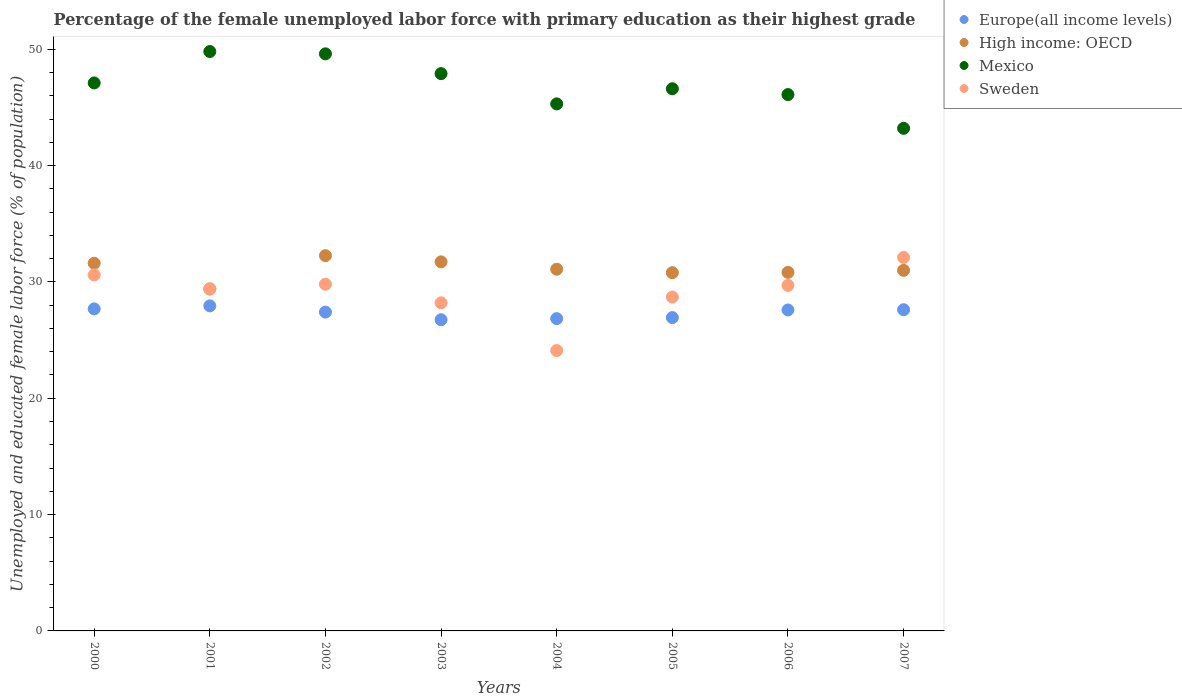How many different coloured dotlines are there?
Your answer should be compact. 4. Is the number of dotlines equal to the number of legend labels?
Ensure brevity in your answer.  Yes. What is the percentage of the unemployed female labor force with primary education in High income: OECD in 2000?
Offer a terse response. 31.6. Across all years, what is the maximum percentage of the unemployed female labor force with primary education in Europe(all income levels)?
Offer a terse response. 27.94. Across all years, what is the minimum percentage of the unemployed female labor force with primary education in Sweden?
Make the answer very short. 24.1. In which year was the percentage of the unemployed female labor force with primary education in Europe(all income levels) maximum?
Give a very brief answer. 2001. In which year was the percentage of the unemployed female labor force with primary education in Sweden minimum?
Give a very brief answer. 2004. What is the total percentage of the unemployed female labor force with primary education in Mexico in the graph?
Your response must be concise. 375.6. What is the difference between the percentage of the unemployed female labor force with primary education in Sweden in 2000 and that in 2006?
Offer a very short reply. 0.9. What is the difference between the percentage of the unemployed female labor force with primary education in Europe(all income levels) in 2004 and the percentage of the unemployed female labor force with primary education in Mexico in 2005?
Provide a short and direct response. -19.76. What is the average percentage of the unemployed female labor force with primary education in Europe(all income levels) per year?
Your response must be concise. 27.34. In the year 2006, what is the difference between the percentage of the unemployed female labor force with primary education in Mexico and percentage of the unemployed female labor force with primary education in Sweden?
Offer a terse response. 16.4. In how many years, is the percentage of the unemployed female labor force with primary education in Mexico greater than 8 %?
Ensure brevity in your answer.  8. What is the ratio of the percentage of the unemployed female labor force with primary education in High income: OECD in 2000 to that in 2007?
Offer a terse response. 1.02. Is the percentage of the unemployed female labor force with primary education in High income: OECD in 2001 less than that in 2005?
Make the answer very short. Yes. What is the difference between the highest and the second highest percentage of the unemployed female labor force with primary education in High income: OECD?
Your answer should be compact. 0.53. What is the difference between the highest and the lowest percentage of the unemployed female labor force with primary education in Mexico?
Make the answer very short. 6.6. Is it the case that in every year, the sum of the percentage of the unemployed female labor force with primary education in Mexico and percentage of the unemployed female labor force with primary education in Europe(all income levels)  is greater than the sum of percentage of the unemployed female labor force with primary education in High income: OECD and percentage of the unemployed female labor force with primary education in Sweden?
Your answer should be compact. Yes. Is it the case that in every year, the sum of the percentage of the unemployed female labor force with primary education in Europe(all income levels) and percentage of the unemployed female labor force with primary education in Mexico  is greater than the percentage of the unemployed female labor force with primary education in High income: OECD?
Keep it short and to the point. Yes. Does the percentage of the unemployed female labor force with primary education in High income: OECD monotonically increase over the years?
Your response must be concise. No. Is the percentage of the unemployed female labor force with primary education in Mexico strictly greater than the percentage of the unemployed female labor force with primary education in Sweden over the years?
Make the answer very short. Yes. Is the percentage of the unemployed female labor force with primary education in Europe(all income levels) strictly less than the percentage of the unemployed female labor force with primary education in High income: OECD over the years?
Your answer should be very brief. Yes. How many years are there in the graph?
Provide a succinct answer. 8. What is the difference between two consecutive major ticks on the Y-axis?
Your response must be concise. 10. Does the graph contain any zero values?
Give a very brief answer. No. Where does the legend appear in the graph?
Provide a short and direct response. Top right. How many legend labels are there?
Provide a succinct answer. 4. How are the legend labels stacked?
Give a very brief answer. Vertical. What is the title of the graph?
Offer a very short reply. Percentage of the female unemployed labor force with primary education as their highest grade. Does "Malta" appear as one of the legend labels in the graph?
Give a very brief answer. No. What is the label or title of the X-axis?
Your answer should be compact. Years. What is the label or title of the Y-axis?
Provide a succinct answer. Unemployed and educated female labor force (% of population). What is the Unemployed and educated female labor force (% of population) of Europe(all income levels) in 2000?
Provide a succinct answer. 27.68. What is the Unemployed and educated female labor force (% of population) of High income: OECD in 2000?
Make the answer very short. 31.6. What is the Unemployed and educated female labor force (% of population) in Mexico in 2000?
Offer a terse response. 47.1. What is the Unemployed and educated female labor force (% of population) of Sweden in 2000?
Make the answer very short. 30.6. What is the Unemployed and educated female labor force (% of population) in Europe(all income levels) in 2001?
Ensure brevity in your answer.  27.94. What is the Unemployed and educated female labor force (% of population) in High income: OECD in 2001?
Your answer should be very brief. 29.39. What is the Unemployed and educated female labor force (% of population) in Mexico in 2001?
Offer a terse response. 49.8. What is the Unemployed and educated female labor force (% of population) in Sweden in 2001?
Provide a short and direct response. 29.4. What is the Unemployed and educated female labor force (% of population) of Europe(all income levels) in 2002?
Offer a very short reply. 27.4. What is the Unemployed and educated female labor force (% of population) of High income: OECD in 2002?
Provide a short and direct response. 32.26. What is the Unemployed and educated female labor force (% of population) of Mexico in 2002?
Offer a terse response. 49.6. What is the Unemployed and educated female labor force (% of population) of Sweden in 2002?
Offer a very short reply. 29.8. What is the Unemployed and educated female labor force (% of population) of Europe(all income levels) in 2003?
Offer a terse response. 26.75. What is the Unemployed and educated female labor force (% of population) in High income: OECD in 2003?
Your answer should be very brief. 31.72. What is the Unemployed and educated female labor force (% of population) in Mexico in 2003?
Your answer should be very brief. 47.9. What is the Unemployed and educated female labor force (% of population) of Sweden in 2003?
Provide a short and direct response. 28.2. What is the Unemployed and educated female labor force (% of population) in Europe(all income levels) in 2004?
Offer a terse response. 26.84. What is the Unemployed and educated female labor force (% of population) of High income: OECD in 2004?
Your response must be concise. 31.09. What is the Unemployed and educated female labor force (% of population) in Mexico in 2004?
Offer a very short reply. 45.3. What is the Unemployed and educated female labor force (% of population) in Sweden in 2004?
Your answer should be compact. 24.1. What is the Unemployed and educated female labor force (% of population) in Europe(all income levels) in 2005?
Your answer should be compact. 26.93. What is the Unemployed and educated female labor force (% of population) in High income: OECD in 2005?
Your response must be concise. 30.79. What is the Unemployed and educated female labor force (% of population) in Mexico in 2005?
Make the answer very short. 46.6. What is the Unemployed and educated female labor force (% of population) in Sweden in 2005?
Make the answer very short. 28.7. What is the Unemployed and educated female labor force (% of population) of Europe(all income levels) in 2006?
Keep it short and to the point. 27.59. What is the Unemployed and educated female labor force (% of population) in High income: OECD in 2006?
Offer a terse response. 30.82. What is the Unemployed and educated female labor force (% of population) of Mexico in 2006?
Ensure brevity in your answer.  46.1. What is the Unemployed and educated female labor force (% of population) of Sweden in 2006?
Offer a very short reply. 29.7. What is the Unemployed and educated female labor force (% of population) in Europe(all income levels) in 2007?
Provide a short and direct response. 27.61. What is the Unemployed and educated female labor force (% of population) of High income: OECD in 2007?
Give a very brief answer. 30.99. What is the Unemployed and educated female labor force (% of population) in Mexico in 2007?
Provide a succinct answer. 43.2. What is the Unemployed and educated female labor force (% of population) of Sweden in 2007?
Your response must be concise. 32.1. Across all years, what is the maximum Unemployed and educated female labor force (% of population) in Europe(all income levels)?
Ensure brevity in your answer.  27.94. Across all years, what is the maximum Unemployed and educated female labor force (% of population) of High income: OECD?
Your answer should be very brief. 32.26. Across all years, what is the maximum Unemployed and educated female labor force (% of population) in Mexico?
Your answer should be very brief. 49.8. Across all years, what is the maximum Unemployed and educated female labor force (% of population) in Sweden?
Provide a succinct answer. 32.1. Across all years, what is the minimum Unemployed and educated female labor force (% of population) in Europe(all income levels)?
Keep it short and to the point. 26.75. Across all years, what is the minimum Unemployed and educated female labor force (% of population) of High income: OECD?
Provide a succinct answer. 29.39. Across all years, what is the minimum Unemployed and educated female labor force (% of population) of Mexico?
Provide a short and direct response. 43.2. Across all years, what is the minimum Unemployed and educated female labor force (% of population) in Sweden?
Provide a short and direct response. 24.1. What is the total Unemployed and educated female labor force (% of population) in Europe(all income levels) in the graph?
Offer a terse response. 218.74. What is the total Unemployed and educated female labor force (% of population) of High income: OECD in the graph?
Your answer should be very brief. 248.66. What is the total Unemployed and educated female labor force (% of population) in Mexico in the graph?
Offer a very short reply. 375.6. What is the total Unemployed and educated female labor force (% of population) of Sweden in the graph?
Provide a succinct answer. 232.6. What is the difference between the Unemployed and educated female labor force (% of population) in Europe(all income levels) in 2000 and that in 2001?
Give a very brief answer. -0.26. What is the difference between the Unemployed and educated female labor force (% of population) of High income: OECD in 2000 and that in 2001?
Make the answer very short. 2.21. What is the difference between the Unemployed and educated female labor force (% of population) in Mexico in 2000 and that in 2001?
Provide a short and direct response. -2.7. What is the difference between the Unemployed and educated female labor force (% of population) in Sweden in 2000 and that in 2001?
Make the answer very short. 1.2. What is the difference between the Unemployed and educated female labor force (% of population) in Europe(all income levels) in 2000 and that in 2002?
Give a very brief answer. 0.28. What is the difference between the Unemployed and educated female labor force (% of population) in High income: OECD in 2000 and that in 2002?
Your response must be concise. -0.65. What is the difference between the Unemployed and educated female labor force (% of population) in Mexico in 2000 and that in 2002?
Offer a terse response. -2.5. What is the difference between the Unemployed and educated female labor force (% of population) in Sweden in 2000 and that in 2002?
Provide a short and direct response. 0.8. What is the difference between the Unemployed and educated female labor force (% of population) in Europe(all income levels) in 2000 and that in 2003?
Provide a short and direct response. 0.93. What is the difference between the Unemployed and educated female labor force (% of population) of High income: OECD in 2000 and that in 2003?
Provide a succinct answer. -0.12. What is the difference between the Unemployed and educated female labor force (% of population) of Mexico in 2000 and that in 2003?
Ensure brevity in your answer.  -0.8. What is the difference between the Unemployed and educated female labor force (% of population) of Sweden in 2000 and that in 2003?
Ensure brevity in your answer.  2.4. What is the difference between the Unemployed and educated female labor force (% of population) of Europe(all income levels) in 2000 and that in 2004?
Provide a succinct answer. 0.84. What is the difference between the Unemployed and educated female labor force (% of population) in High income: OECD in 2000 and that in 2004?
Provide a succinct answer. 0.51. What is the difference between the Unemployed and educated female labor force (% of population) in Sweden in 2000 and that in 2004?
Make the answer very short. 6.5. What is the difference between the Unemployed and educated female labor force (% of population) of Europe(all income levels) in 2000 and that in 2005?
Your response must be concise. 0.75. What is the difference between the Unemployed and educated female labor force (% of population) in High income: OECD in 2000 and that in 2005?
Keep it short and to the point. 0.81. What is the difference between the Unemployed and educated female labor force (% of population) of Mexico in 2000 and that in 2005?
Your response must be concise. 0.5. What is the difference between the Unemployed and educated female labor force (% of population) of Europe(all income levels) in 2000 and that in 2006?
Give a very brief answer. 0.09. What is the difference between the Unemployed and educated female labor force (% of population) of High income: OECD in 2000 and that in 2006?
Ensure brevity in your answer.  0.79. What is the difference between the Unemployed and educated female labor force (% of population) of Sweden in 2000 and that in 2006?
Make the answer very short. 0.9. What is the difference between the Unemployed and educated female labor force (% of population) in Europe(all income levels) in 2000 and that in 2007?
Your response must be concise. 0.07. What is the difference between the Unemployed and educated female labor force (% of population) of High income: OECD in 2000 and that in 2007?
Make the answer very short. 0.61. What is the difference between the Unemployed and educated female labor force (% of population) in Europe(all income levels) in 2001 and that in 2002?
Provide a short and direct response. 0.53. What is the difference between the Unemployed and educated female labor force (% of population) in High income: OECD in 2001 and that in 2002?
Offer a very short reply. -2.86. What is the difference between the Unemployed and educated female labor force (% of population) in Mexico in 2001 and that in 2002?
Keep it short and to the point. 0.2. What is the difference between the Unemployed and educated female labor force (% of population) in Sweden in 2001 and that in 2002?
Your answer should be compact. -0.4. What is the difference between the Unemployed and educated female labor force (% of population) in Europe(all income levels) in 2001 and that in 2003?
Your response must be concise. 1.19. What is the difference between the Unemployed and educated female labor force (% of population) in High income: OECD in 2001 and that in 2003?
Make the answer very short. -2.33. What is the difference between the Unemployed and educated female labor force (% of population) of Mexico in 2001 and that in 2003?
Offer a very short reply. 1.9. What is the difference between the Unemployed and educated female labor force (% of population) in Europe(all income levels) in 2001 and that in 2004?
Provide a succinct answer. 1.1. What is the difference between the Unemployed and educated female labor force (% of population) of High income: OECD in 2001 and that in 2004?
Make the answer very short. -1.7. What is the difference between the Unemployed and educated female labor force (% of population) in Sweden in 2001 and that in 2004?
Your answer should be very brief. 5.3. What is the difference between the Unemployed and educated female labor force (% of population) of Europe(all income levels) in 2001 and that in 2005?
Your answer should be compact. 1.01. What is the difference between the Unemployed and educated female labor force (% of population) of High income: OECD in 2001 and that in 2005?
Offer a terse response. -1.4. What is the difference between the Unemployed and educated female labor force (% of population) of Mexico in 2001 and that in 2005?
Offer a terse response. 3.2. What is the difference between the Unemployed and educated female labor force (% of population) in Europe(all income levels) in 2001 and that in 2006?
Provide a succinct answer. 0.35. What is the difference between the Unemployed and educated female labor force (% of population) of High income: OECD in 2001 and that in 2006?
Offer a terse response. -1.42. What is the difference between the Unemployed and educated female labor force (% of population) of Mexico in 2001 and that in 2006?
Your answer should be compact. 3.7. What is the difference between the Unemployed and educated female labor force (% of population) in Europe(all income levels) in 2001 and that in 2007?
Make the answer very short. 0.33. What is the difference between the Unemployed and educated female labor force (% of population) in High income: OECD in 2001 and that in 2007?
Provide a short and direct response. -1.6. What is the difference between the Unemployed and educated female labor force (% of population) of Mexico in 2001 and that in 2007?
Provide a succinct answer. 6.6. What is the difference between the Unemployed and educated female labor force (% of population) in Sweden in 2001 and that in 2007?
Keep it short and to the point. -2.7. What is the difference between the Unemployed and educated female labor force (% of population) in Europe(all income levels) in 2002 and that in 2003?
Make the answer very short. 0.66. What is the difference between the Unemployed and educated female labor force (% of population) in High income: OECD in 2002 and that in 2003?
Provide a short and direct response. 0.53. What is the difference between the Unemployed and educated female labor force (% of population) of Mexico in 2002 and that in 2003?
Offer a very short reply. 1.7. What is the difference between the Unemployed and educated female labor force (% of population) of Europe(all income levels) in 2002 and that in 2004?
Provide a short and direct response. 0.56. What is the difference between the Unemployed and educated female labor force (% of population) of High income: OECD in 2002 and that in 2004?
Offer a terse response. 1.17. What is the difference between the Unemployed and educated female labor force (% of population) of Europe(all income levels) in 2002 and that in 2005?
Provide a succinct answer. 0.47. What is the difference between the Unemployed and educated female labor force (% of population) in High income: OECD in 2002 and that in 2005?
Offer a terse response. 1.46. What is the difference between the Unemployed and educated female labor force (% of population) in Sweden in 2002 and that in 2005?
Your response must be concise. 1.1. What is the difference between the Unemployed and educated female labor force (% of population) of Europe(all income levels) in 2002 and that in 2006?
Your answer should be compact. -0.18. What is the difference between the Unemployed and educated female labor force (% of population) in High income: OECD in 2002 and that in 2006?
Give a very brief answer. 1.44. What is the difference between the Unemployed and educated female labor force (% of population) in Europe(all income levels) in 2002 and that in 2007?
Make the answer very short. -0.2. What is the difference between the Unemployed and educated female labor force (% of population) in High income: OECD in 2002 and that in 2007?
Keep it short and to the point. 1.26. What is the difference between the Unemployed and educated female labor force (% of population) in Mexico in 2002 and that in 2007?
Offer a very short reply. 6.4. What is the difference between the Unemployed and educated female labor force (% of population) in Europe(all income levels) in 2003 and that in 2004?
Provide a succinct answer. -0.1. What is the difference between the Unemployed and educated female labor force (% of population) of High income: OECD in 2003 and that in 2004?
Keep it short and to the point. 0.63. What is the difference between the Unemployed and educated female labor force (% of population) in Sweden in 2003 and that in 2004?
Your answer should be compact. 4.1. What is the difference between the Unemployed and educated female labor force (% of population) of Europe(all income levels) in 2003 and that in 2005?
Make the answer very short. -0.18. What is the difference between the Unemployed and educated female labor force (% of population) of High income: OECD in 2003 and that in 2005?
Offer a very short reply. 0.93. What is the difference between the Unemployed and educated female labor force (% of population) of Mexico in 2003 and that in 2005?
Offer a terse response. 1.3. What is the difference between the Unemployed and educated female labor force (% of population) of Sweden in 2003 and that in 2005?
Your answer should be very brief. -0.5. What is the difference between the Unemployed and educated female labor force (% of population) of Europe(all income levels) in 2003 and that in 2006?
Give a very brief answer. -0.84. What is the difference between the Unemployed and educated female labor force (% of population) in High income: OECD in 2003 and that in 2006?
Offer a very short reply. 0.9. What is the difference between the Unemployed and educated female labor force (% of population) in Mexico in 2003 and that in 2006?
Offer a very short reply. 1.8. What is the difference between the Unemployed and educated female labor force (% of population) in Sweden in 2003 and that in 2006?
Your answer should be very brief. -1.5. What is the difference between the Unemployed and educated female labor force (% of population) in Europe(all income levels) in 2003 and that in 2007?
Provide a succinct answer. -0.86. What is the difference between the Unemployed and educated female labor force (% of population) of High income: OECD in 2003 and that in 2007?
Offer a terse response. 0.73. What is the difference between the Unemployed and educated female labor force (% of population) of Europe(all income levels) in 2004 and that in 2005?
Offer a terse response. -0.09. What is the difference between the Unemployed and educated female labor force (% of population) of High income: OECD in 2004 and that in 2005?
Offer a very short reply. 0.3. What is the difference between the Unemployed and educated female labor force (% of population) of Sweden in 2004 and that in 2005?
Ensure brevity in your answer.  -4.6. What is the difference between the Unemployed and educated female labor force (% of population) of Europe(all income levels) in 2004 and that in 2006?
Your answer should be compact. -0.75. What is the difference between the Unemployed and educated female labor force (% of population) in High income: OECD in 2004 and that in 2006?
Provide a short and direct response. 0.27. What is the difference between the Unemployed and educated female labor force (% of population) of Mexico in 2004 and that in 2006?
Your response must be concise. -0.8. What is the difference between the Unemployed and educated female labor force (% of population) of Sweden in 2004 and that in 2006?
Your answer should be compact. -5.6. What is the difference between the Unemployed and educated female labor force (% of population) of Europe(all income levels) in 2004 and that in 2007?
Your answer should be compact. -0.76. What is the difference between the Unemployed and educated female labor force (% of population) in High income: OECD in 2004 and that in 2007?
Ensure brevity in your answer.  0.1. What is the difference between the Unemployed and educated female labor force (% of population) in Europe(all income levels) in 2005 and that in 2006?
Provide a short and direct response. -0.66. What is the difference between the Unemployed and educated female labor force (% of population) in High income: OECD in 2005 and that in 2006?
Offer a very short reply. -0.02. What is the difference between the Unemployed and educated female labor force (% of population) in Sweden in 2005 and that in 2006?
Your answer should be very brief. -1. What is the difference between the Unemployed and educated female labor force (% of population) in Europe(all income levels) in 2005 and that in 2007?
Provide a succinct answer. -0.68. What is the difference between the Unemployed and educated female labor force (% of population) in High income: OECD in 2005 and that in 2007?
Offer a terse response. -0.2. What is the difference between the Unemployed and educated female labor force (% of population) of Sweden in 2005 and that in 2007?
Make the answer very short. -3.4. What is the difference between the Unemployed and educated female labor force (% of population) in Europe(all income levels) in 2006 and that in 2007?
Ensure brevity in your answer.  -0.02. What is the difference between the Unemployed and educated female labor force (% of population) in High income: OECD in 2006 and that in 2007?
Give a very brief answer. -0.18. What is the difference between the Unemployed and educated female labor force (% of population) of Europe(all income levels) in 2000 and the Unemployed and educated female labor force (% of population) of High income: OECD in 2001?
Give a very brief answer. -1.71. What is the difference between the Unemployed and educated female labor force (% of population) of Europe(all income levels) in 2000 and the Unemployed and educated female labor force (% of population) of Mexico in 2001?
Keep it short and to the point. -22.12. What is the difference between the Unemployed and educated female labor force (% of population) of Europe(all income levels) in 2000 and the Unemployed and educated female labor force (% of population) of Sweden in 2001?
Ensure brevity in your answer.  -1.72. What is the difference between the Unemployed and educated female labor force (% of population) of High income: OECD in 2000 and the Unemployed and educated female labor force (% of population) of Mexico in 2001?
Offer a very short reply. -18.2. What is the difference between the Unemployed and educated female labor force (% of population) of High income: OECD in 2000 and the Unemployed and educated female labor force (% of population) of Sweden in 2001?
Your answer should be compact. 2.2. What is the difference between the Unemployed and educated female labor force (% of population) in Mexico in 2000 and the Unemployed and educated female labor force (% of population) in Sweden in 2001?
Your response must be concise. 17.7. What is the difference between the Unemployed and educated female labor force (% of population) of Europe(all income levels) in 2000 and the Unemployed and educated female labor force (% of population) of High income: OECD in 2002?
Offer a very short reply. -4.58. What is the difference between the Unemployed and educated female labor force (% of population) in Europe(all income levels) in 2000 and the Unemployed and educated female labor force (% of population) in Mexico in 2002?
Offer a very short reply. -21.92. What is the difference between the Unemployed and educated female labor force (% of population) in Europe(all income levels) in 2000 and the Unemployed and educated female labor force (% of population) in Sweden in 2002?
Your answer should be very brief. -2.12. What is the difference between the Unemployed and educated female labor force (% of population) of High income: OECD in 2000 and the Unemployed and educated female labor force (% of population) of Mexico in 2002?
Provide a short and direct response. -18. What is the difference between the Unemployed and educated female labor force (% of population) of High income: OECD in 2000 and the Unemployed and educated female labor force (% of population) of Sweden in 2002?
Keep it short and to the point. 1.8. What is the difference between the Unemployed and educated female labor force (% of population) in Mexico in 2000 and the Unemployed and educated female labor force (% of population) in Sweden in 2002?
Keep it short and to the point. 17.3. What is the difference between the Unemployed and educated female labor force (% of population) in Europe(all income levels) in 2000 and the Unemployed and educated female labor force (% of population) in High income: OECD in 2003?
Provide a succinct answer. -4.04. What is the difference between the Unemployed and educated female labor force (% of population) in Europe(all income levels) in 2000 and the Unemployed and educated female labor force (% of population) in Mexico in 2003?
Offer a very short reply. -20.22. What is the difference between the Unemployed and educated female labor force (% of population) in Europe(all income levels) in 2000 and the Unemployed and educated female labor force (% of population) in Sweden in 2003?
Give a very brief answer. -0.52. What is the difference between the Unemployed and educated female labor force (% of population) in High income: OECD in 2000 and the Unemployed and educated female labor force (% of population) in Mexico in 2003?
Offer a very short reply. -16.3. What is the difference between the Unemployed and educated female labor force (% of population) in High income: OECD in 2000 and the Unemployed and educated female labor force (% of population) in Sweden in 2003?
Ensure brevity in your answer.  3.4. What is the difference between the Unemployed and educated female labor force (% of population) in Europe(all income levels) in 2000 and the Unemployed and educated female labor force (% of population) in High income: OECD in 2004?
Offer a very short reply. -3.41. What is the difference between the Unemployed and educated female labor force (% of population) of Europe(all income levels) in 2000 and the Unemployed and educated female labor force (% of population) of Mexico in 2004?
Provide a short and direct response. -17.62. What is the difference between the Unemployed and educated female labor force (% of population) of Europe(all income levels) in 2000 and the Unemployed and educated female labor force (% of population) of Sweden in 2004?
Provide a short and direct response. 3.58. What is the difference between the Unemployed and educated female labor force (% of population) of High income: OECD in 2000 and the Unemployed and educated female labor force (% of population) of Mexico in 2004?
Keep it short and to the point. -13.7. What is the difference between the Unemployed and educated female labor force (% of population) in High income: OECD in 2000 and the Unemployed and educated female labor force (% of population) in Sweden in 2004?
Ensure brevity in your answer.  7.5. What is the difference between the Unemployed and educated female labor force (% of population) of Europe(all income levels) in 2000 and the Unemployed and educated female labor force (% of population) of High income: OECD in 2005?
Provide a succinct answer. -3.11. What is the difference between the Unemployed and educated female labor force (% of population) in Europe(all income levels) in 2000 and the Unemployed and educated female labor force (% of population) in Mexico in 2005?
Your answer should be compact. -18.92. What is the difference between the Unemployed and educated female labor force (% of population) in Europe(all income levels) in 2000 and the Unemployed and educated female labor force (% of population) in Sweden in 2005?
Your response must be concise. -1.02. What is the difference between the Unemployed and educated female labor force (% of population) of High income: OECD in 2000 and the Unemployed and educated female labor force (% of population) of Mexico in 2005?
Provide a short and direct response. -15. What is the difference between the Unemployed and educated female labor force (% of population) in High income: OECD in 2000 and the Unemployed and educated female labor force (% of population) in Sweden in 2005?
Your response must be concise. 2.9. What is the difference between the Unemployed and educated female labor force (% of population) in Mexico in 2000 and the Unemployed and educated female labor force (% of population) in Sweden in 2005?
Make the answer very short. 18.4. What is the difference between the Unemployed and educated female labor force (% of population) in Europe(all income levels) in 2000 and the Unemployed and educated female labor force (% of population) in High income: OECD in 2006?
Offer a very short reply. -3.14. What is the difference between the Unemployed and educated female labor force (% of population) of Europe(all income levels) in 2000 and the Unemployed and educated female labor force (% of population) of Mexico in 2006?
Provide a succinct answer. -18.42. What is the difference between the Unemployed and educated female labor force (% of population) in Europe(all income levels) in 2000 and the Unemployed and educated female labor force (% of population) in Sweden in 2006?
Provide a short and direct response. -2.02. What is the difference between the Unemployed and educated female labor force (% of population) of High income: OECD in 2000 and the Unemployed and educated female labor force (% of population) of Mexico in 2006?
Give a very brief answer. -14.5. What is the difference between the Unemployed and educated female labor force (% of population) of High income: OECD in 2000 and the Unemployed and educated female labor force (% of population) of Sweden in 2006?
Provide a succinct answer. 1.9. What is the difference between the Unemployed and educated female labor force (% of population) in Europe(all income levels) in 2000 and the Unemployed and educated female labor force (% of population) in High income: OECD in 2007?
Provide a succinct answer. -3.31. What is the difference between the Unemployed and educated female labor force (% of population) in Europe(all income levels) in 2000 and the Unemployed and educated female labor force (% of population) in Mexico in 2007?
Make the answer very short. -15.52. What is the difference between the Unemployed and educated female labor force (% of population) of Europe(all income levels) in 2000 and the Unemployed and educated female labor force (% of population) of Sweden in 2007?
Your answer should be very brief. -4.42. What is the difference between the Unemployed and educated female labor force (% of population) of High income: OECD in 2000 and the Unemployed and educated female labor force (% of population) of Mexico in 2007?
Give a very brief answer. -11.6. What is the difference between the Unemployed and educated female labor force (% of population) of High income: OECD in 2000 and the Unemployed and educated female labor force (% of population) of Sweden in 2007?
Keep it short and to the point. -0.5. What is the difference between the Unemployed and educated female labor force (% of population) of Europe(all income levels) in 2001 and the Unemployed and educated female labor force (% of population) of High income: OECD in 2002?
Your response must be concise. -4.32. What is the difference between the Unemployed and educated female labor force (% of population) of Europe(all income levels) in 2001 and the Unemployed and educated female labor force (% of population) of Mexico in 2002?
Make the answer very short. -21.66. What is the difference between the Unemployed and educated female labor force (% of population) in Europe(all income levels) in 2001 and the Unemployed and educated female labor force (% of population) in Sweden in 2002?
Your answer should be compact. -1.86. What is the difference between the Unemployed and educated female labor force (% of population) in High income: OECD in 2001 and the Unemployed and educated female labor force (% of population) in Mexico in 2002?
Give a very brief answer. -20.21. What is the difference between the Unemployed and educated female labor force (% of population) of High income: OECD in 2001 and the Unemployed and educated female labor force (% of population) of Sweden in 2002?
Keep it short and to the point. -0.41. What is the difference between the Unemployed and educated female labor force (% of population) in Europe(all income levels) in 2001 and the Unemployed and educated female labor force (% of population) in High income: OECD in 2003?
Keep it short and to the point. -3.78. What is the difference between the Unemployed and educated female labor force (% of population) of Europe(all income levels) in 2001 and the Unemployed and educated female labor force (% of population) of Mexico in 2003?
Offer a very short reply. -19.96. What is the difference between the Unemployed and educated female labor force (% of population) in Europe(all income levels) in 2001 and the Unemployed and educated female labor force (% of population) in Sweden in 2003?
Offer a very short reply. -0.26. What is the difference between the Unemployed and educated female labor force (% of population) in High income: OECD in 2001 and the Unemployed and educated female labor force (% of population) in Mexico in 2003?
Make the answer very short. -18.51. What is the difference between the Unemployed and educated female labor force (% of population) of High income: OECD in 2001 and the Unemployed and educated female labor force (% of population) of Sweden in 2003?
Provide a short and direct response. 1.19. What is the difference between the Unemployed and educated female labor force (% of population) in Mexico in 2001 and the Unemployed and educated female labor force (% of population) in Sweden in 2003?
Ensure brevity in your answer.  21.6. What is the difference between the Unemployed and educated female labor force (% of population) in Europe(all income levels) in 2001 and the Unemployed and educated female labor force (% of population) in High income: OECD in 2004?
Your answer should be very brief. -3.15. What is the difference between the Unemployed and educated female labor force (% of population) of Europe(all income levels) in 2001 and the Unemployed and educated female labor force (% of population) of Mexico in 2004?
Offer a terse response. -17.36. What is the difference between the Unemployed and educated female labor force (% of population) in Europe(all income levels) in 2001 and the Unemployed and educated female labor force (% of population) in Sweden in 2004?
Provide a short and direct response. 3.84. What is the difference between the Unemployed and educated female labor force (% of population) in High income: OECD in 2001 and the Unemployed and educated female labor force (% of population) in Mexico in 2004?
Give a very brief answer. -15.91. What is the difference between the Unemployed and educated female labor force (% of population) of High income: OECD in 2001 and the Unemployed and educated female labor force (% of population) of Sweden in 2004?
Ensure brevity in your answer.  5.29. What is the difference between the Unemployed and educated female labor force (% of population) of Mexico in 2001 and the Unemployed and educated female labor force (% of population) of Sweden in 2004?
Offer a terse response. 25.7. What is the difference between the Unemployed and educated female labor force (% of population) of Europe(all income levels) in 2001 and the Unemployed and educated female labor force (% of population) of High income: OECD in 2005?
Your answer should be very brief. -2.85. What is the difference between the Unemployed and educated female labor force (% of population) of Europe(all income levels) in 2001 and the Unemployed and educated female labor force (% of population) of Mexico in 2005?
Your answer should be very brief. -18.66. What is the difference between the Unemployed and educated female labor force (% of population) in Europe(all income levels) in 2001 and the Unemployed and educated female labor force (% of population) in Sweden in 2005?
Ensure brevity in your answer.  -0.76. What is the difference between the Unemployed and educated female labor force (% of population) of High income: OECD in 2001 and the Unemployed and educated female labor force (% of population) of Mexico in 2005?
Keep it short and to the point. -17.21. What is the difference between the Unemployed and educated female labor force (% of population) in High income: OECD in 2001 and the Unemployed and educated female labor force (% of population) in Sweden in 2005?
Make the answer very short. 0.69. What is the difference between the Unemployed and educated female labor force (% of population) in Mexico in 2001 and the Unemployed and educated female labor force (% of population) in Sweden in 2005?
Your answer should be very brief. 21.1. What is the difference between the Unemployed and educated female labor force (% of population) in Europe(all income levels) in 2001 and the Unemployed and educated female labor force (% of population) in High income: OECD in 2006?
Provide a succinct answer. -2.88. What is the difference between the Unemployed and educated female labor force (% of population) of Europe(all income levels) in 2001 and the Unemployed and educated female labor force (% of population) of Mexico in 2006?
Your response must be concise. -18.16. What is the difference between the Unemployed and educated female labor force (% of population) in Europe(all income levels) in 2001 and the Unemployed and educated female labor force (% of population) in Sweden in 2006?
Your answer should be very brief. -1.76. What is the difference between the Unemployed and educated female labor force (% of population) of High income: OECD in 2001 and the Unemployed and educated female labor force (% of population) of Mexico in 2006?
Provide a succinct answer. -16.71. What is the difference between the Unemployed and educated female labor force (% of population) of High income: OECD in 2001 and the Unemployed and educated female labor force (% of population) of Sweden in 2006?
Your answer should be compact. -0.31. What is the difference between the Unemployed and educated female labor force (% of population) of Mexico in 2001 and the Unemployed and educated female labor force (% of population) of Sweden in 2006?
Provide a short and direct response. 20.1. What is the difference between the Unemployed and educated female labor force (% of population) of Europe(all income levels) in 2001 and the Unemployed and educated female labor force (% of population) of High income: OECD in 2007?
Provide a short and direct response. -3.05. What is the difference between the Unemployed and educated female labor force (% of population) of Europe(all income levels) in 2001 and the Unemployed and educated female labor force (% of population) of Mexico in 2007?
Offer a very short reply. -15.26. What is the difference between the Unemployed and educated female labor force (% of population) of Europe(all income levels) in 2001 and the Unemployed and educated female labor force (% of population) of Sweden in 2007?
Make the answer very short. -4.16. What is the difference between the Unemployed and educated female labor force (% of population) in High income: OECD in 2001 and the Unemployed and educated female labor force (% of population) in Mexico in 2007?
Keep it short and to the point. -13.81. What is the difference between the Unemployed and educated female labor force (% of population) of High income: OECD in 2001 and the Unemployed and educated female labor force (% of population) of Sweden in 2007?
Ensure brevity in your answer.  -2.71. What is the difference between the Unemployed and educated female labor force (% of population) in Europe(all income levels) in 2002 and the Unemployed and educated female labor force (% of population) in High income: OECD in 2003?
Your answer should be compact. -4.32. What is the difference between the Unemployed and educated female labor force (% of population) in Europe(all income levels) in 2002 and the Unemployed and educated female labor force (% of population) in Mexico in 2003?
Offer a very short reply. -20.5. What is the difference between the Unemployed and educated female labor force (% of population) in Europe(all income levels) in 2002 and the Unemployed and educated female labor force (% of population) in Sweden in 2003?
Offer a terse response. -0.8. What is the difference between the Unemployed and educated female labor force (% of population) in High income: OECD in 2002 and the Unemployed and educated female labor force (% of population) in Mexico in 2003?
Provide a short and direct response. -15.64. What is the difference between the Unemployed and educated female labor force (% of population) in High income: OECD in 2002 and the Unemployed and educated female labor force (% of population) in Sweden in 2003?
Your answer should be very brief. 4.06. What is the difference between the Unemployed and educated female labor force (% of population) in Mexico in 2002 and the Unemployed and educated female labor force (% of population) in Sweden in 2003?
Ensure brevity in your answer.  21.4. What is the difference between the Unemployed and educated female labor force (% of population) in Europe(all income levels) in 2002 and the Unemployed and educated female labor force (% of population) in High income: OECD in 2004?
Offer a terse response. -3.69. What is the difference between the Unemployed and educated female labor force (% of population) in Europe(all income levels) in 2002 and the Unemployed and educated female labor force (% of population) in Mexico in 2004?
Make the answer very short. -17.9. What is the difference between the Unemployed and educated female labor force (% of population) in Europe(all income levels) in 2002 and the Unemployed and educated female labor force (% of population) in Sweden in 2004?
Offer a very short reply. 3.3. What is the difference between the Unemployed and educated female labor force (% of population) in High income: OECD in 2002 and the Unemployed and educated female labor force (% of population) in Mexico in 2004?
Your response must be concise. -13.04. What is the difference between the Unemployed and educated female labor force (% of population) of High income: OECD in 2002 and the Unemployed and educated female labor force (% of population) of Sweden in 2004?
Provide a succinct answer. 8.16. What is the difference between the Unemployed and educated female labor force (% of population) in Europe(all income levels) in 2002 and the Unemployed and educated female labor force (% of population) in High income: OECD in 2005?
Your response must be concise. -3.39. What is the difference between the Unemployed and educated female labor force (% of population) in Europe(all income levels) in 2002 and the Unemployed and educated female labor force (% of population) in Mexico in 2005?
Your answer should be very brief. -19.2. What is the difference between the Unemployed and educated female labor force (% of population) of Europe(all income levels) in 2002 and the Unemployed and educated female labor force (% of population) of Sweden in 2005?
Your answer should be compact. -1.3. What is the difference between the Unemployed and educated female labor force (% of population) of High income: OECD in 2002 and the Unemployed and educated female labor force (% of population) of Mexico in 2005?
Give a very brief answer. -14.34. What is the difference between the Unemployed and educated female labor force (% of population) in High income: OECD in 2002 and the Unemployed and educated female labor force (% of population) in Sweden in 2005?
Ensure brevity in your answer.  3.56. What is the difference between the Unemployed and educated female labor force (% of population) of Mexico in 2002 and the Unemployed and educated female labor force (% of population) of Sweden in 2005?
Offer a very short reply. 20.9. What is the difference between the Unemployed and educated female labor force (% of population) of Europe(all income levels) in 2002 and the Unemployed and educated female labor force (% of population) of High income: OECD in 2006?
Your answer should be very brief. -3.41. What is the difference between the Unemployed and educated female labor force (% of population) in Europe(all income levels) in 2002 and the Unemployed and educated female labor force (% of population) in Mexico in 2006?
Your answer should be compact. -18.7. What is the difference between the Unemployed and educated female labor force (% of population) of Europe(all income levels) in 2002 and the Unemployed and educated female labor force (% of population) of Sweden in 2006?
Your answer should be compact. -2.3. What is the difference between the Unemployed and educated female labor force (% of population) of High income: OECD in 2002 and the Unemployed and educated female labor force (% of population) of Mexico in 2006?
Offer a very short reply. -13.84. What is the difference between the Unemployed and educated female labor force (% of population) in High income: OECD in 2002 and the Unemployed and educated female labor force (% of population) in Sweden in 2006?
Your response must be concise. 2.56. What is the difference between the Unemployed and educated female labor force (% of population) of Mexico in 2002 and the Unemployed and educated female labor force (% of population) of Sweden in 2006?
Ensure brevity in your answer.  19.9. What is the difference between the Unemployed and educated female labor force (% of population) of Europe(all income levels) in 2002 and the Unemployed and educated female labor force (% of population) of High income: OECD in 2007?
Offer a terse response. -3.59. What is the difference between the Unemployed and educated female labor force (% of population) in Europe(all income levels) in 2002 and the Unemployed and educated female labor force (% of population) in Mexico in 2007?
Offer a terse response. -15.8. What is the difference between the Unemployed and educated female labor force (% of population) of Europe(all income levels) in 2002 and the Unemployed and educated female labor force (% of population) of Sweden in 2007?
Keep it short and to the point. -4.7. What is the difference between the Unemployed and educated female labor force (% of population) in High income: OECD in 2002 and the Unemployed and educated female labor force (% of population) in Mexico in 2007?
Provide a short and direct response. -10.94. What is the difference between the Unemployed and educated female labor force (% of population) in High income: OECD in 2002 and the Unemployed and educated female labor force (% of population) in Sweden in 2007?
Your answer should be very brief. 0.16. What is the difference between the Unemployed and educated female labor force (% of population) in Europe(all income levels) in 2003 and the Unemployed and educated female labor force (% of population) in High income: OECD in 2004?
Keep it short and to the point. -4.34. What is the difference between the Unemployed and educated female labor force (% of population) in Europe(all income levels) in 2003 and the Unemployed and educated female labor force (% of population) in Mexico in 2004?
Offer a terse response. -18.55. What is the difference between the Unemployed and educated female labor force (% of population) in Europe(all income levels) in 2003 and the Unemployed and educated female labor force (% of population) in Sweden in 2004?
Provide a succinct answer. 2.65. What is the difference between the Unemployed and educated female labor force (% of population) in High income: OECD in 2003 and the Unemployed and educated female labor force (% of population) in Mexico in 2004?
Your response must be concise. -13.58. What is the difference between the Unemployed and educated female labor force (% of population) of High income: OECD in 2003 and the Unemployed and educated female labor force (% of population) of Sweden in 2004?
Offer a terse response. 7.62. What is the difference between the Unemployed and educated female labor force (% of population) of Mexico in 2003 and the Unemployed and educated female labor force (% of population) of Sweden in 2004?
Offer a very short reply. 23.8. What is the difference between the Unemployed and educated female labor force (% of population) of Europe(all income levels) in 2003 and the Unemployed and educated female labor force (% of population) of High income: OECD in 2005?
Provide a succinct answer. -4.05. What is the difference between the Unemployed and educated female labor force (% of population) in Europe(all income levels) in 2003 and the Unemployed and educated female labor force (% of population) in Mexico in 2005?
Offer a very short reply. -19.85. What is the difference between the Unemployed and educated female labor force (% of population) in Europe(all income levels) in 2003 and the Unemployed and educated female labor force (% of population) in Sweden in 2005?
Your response must be concise. -1.95. What is the difference between the Unemployed and educated female labor force (% of population) in High income: OECD in 2003 and the Unemployed and educated female labor force (% of population) in Mexico in 2005?
Ensure brevity in your answer.  -14.88. What is the difference between the Unemployed and educated female labor force (% of population) in High income: OECD in 2003 and the Unemployed and educated female labor force (% of population) in Sweden in 2005?
Ensure brevity in your answer.  3.02. What is the difference between the Unemployed and educated female labor force (% of population) in Europe(all income levels) in 2003 and the Unemployed and educated female labor force (% of population) in High income: OECD in 2006?
Your answer should be compact. -4.07. What is the difference between the Unemployed and educated female labor force (% of population) in Europe(all income levels) in 2003 and the Unemployed and educated female labor force (% of population) in Mexico in 2006?
Keep it short and to the point. -19.35. What is the difference between the Unemployed and educated female labor force (% of population) in Europe(all income levels) in 2003 and the Unemployed and educated female labor force (% of population) in Sweden in 2006?
Your answer should be compact. -2.95. What is the difference between the Unemployed and educated female labor force (% of population) of High income: OECD in 2003 and the Unemployed and educated female labor force (% of population) of Mexico in 2006?
Keep it short and to the point. -14.38. What is the difference between the Unemployed and educated female labor force (% of population) in High income: OECD in 2003 and the Unemployed and educated female labor force (% of population) in Sweden in 2006?
Ensure brevity in your answer.  2.02. What is the difference between the Unemployed and educated female labor force (% of population) in Mexico in 2003 and the Unemployed and educated female labor force (% of population) in Sweden in 2006?
Your response must be concise. 18.2. What is the difference between the Unemployed and educated female labor force (% of population) of Europe(all income levels) in 2003 and the Unemployed and educated female labor force (% of population) of High income: OECD in 2007?
Give a very brief answer. -4.24. What is the difference between the Unemployed and educated female labor force (% of population) of Europe(all income levels) in 2003 and the Unemployed and educated female labor force (% of population) of Mexico in 2007?
Give a very brief answer. -16.45. What is the difference between the Unemployed and educated female labor force (% of population) of Europe(all income levels) in 2003 and the Unemployed and educated female labor force (% of population) of Sweden in 2007?
Offer a terse response. -5.35. What is the difference between the Unemployed and educated female labor force (% of population) in High income: OECD in 2003 and the Unemployed and educated female labor force (% of population) in Mexico in 2007?
Give a very brief answer. -11.48. What is the difference between the Unemployed and educated female labor force (% of population) of High income: OECD in 2003 and the Unemployed and educated female labor force (% of population) of Sweden in 2007?
Ensure brevity in your answer.  -0.38. What is the difference between the Unemployed and educated female labor force (% of population) of Mexico in 2003 and the Unemployed and educated female labor force (% of population) of Sweden in 2007?
Provide a succinct answer. 15.8. What is the difference between the Unemployed and educated female labor force (% of population) in Europe(all income levels) in 2004 and the Unemployed and educated female labor force (% of population) in High income: OECD in 2005?
Offer a very short reply. -3.95. What is the difference between the Unemployed and educated female labor force (% of population) of Europe(all income levels) in 2004 and the Unemployed and educated female labor force (% of population) of Mexico in 2005?
Offer a very short reply. -19.76. What is the difference between the Unemployed and educated female labor force (% of population) in Europe(all income levels) in 2004 and the Unemployed and educated female labor force (% of population) in Sweden in 2005?
Make the answer very short. -1.86. What is the difference between the Unemployed and educated female labor force (% of population) in High income: OECD in 2004 and the Unemployed and educated female labor force (% of population) in Mexico in 2005?
Keep it short and to the point. -15.51. What is the difference between the Unemployed and educated female labor force (% of population) of High income: OECD in 2004 and the Unemployed and educated female labor force (% of population) of Sweden in 2005?
Offer a terse response. 2.39. What is the difference between the Unemployed and educated female labor force (% of population) of Europe(all income levels) in 2004 and the Unemployed and educated female labor force (% of population) of High income: OECD in 2006?
Make the answer very short. -3.97. What is the difference between the Unemployed and educated female labor force (% of population) in Europe(all income levels) in 2004 and the Unemployed and educated female labor force (% of population) in Mexico in 2006?
Give a very brief answer. -19.26. What is the difference between the Unemployed and educated female labor force (% of population) of Europe(all income levels) in 2004 and the Unemployed and educated female labor force (% of population) of Sweden in 2006?
Make the answer very short. -2.86. What is the difference between the Unemployed and educated female labor force (% of population) of High income: OECD in 2004 and the Unemployed and educated female labor force (% of population) of Mexico in 2006?
Your answer should be compact. -15.01. What is the difference between the Unemployed and educated female labor force (% of population) of High income: OECD in 2004 and the Unemployed and educated female labor force (% of population) of Sweden in 2006?
Ensure brevity in your answer.  1.39. What is the difference between the Unemployed and educated female labor force (% of population) in Mexico in 2004 and the Unemployed and educated female labor force (% of population) in Sweden in 2006?
Ensure brevity in your answer.  15.6. What is the difference between the Unemployed and educated female labor force (% of population) of Europe(all income levels) in 2004 and the Unemployed and educated female labor force (% of population) of High income: OECD in 2007?
Provide a short and direct response. -4.15. What is the difference between the Unemployed and educated female labor force (% of population) in Europe(all income levels) in 2004 and the Unemployed and educated female labor force (% of population) in Mexico in 2007?
Give a very brief answer. -16.36. What is the difference between the Unemployed and educated female labor force (% of population) of Europe(all income levels) in 2004 and the Unemployed and educated female labor force (% of population) of Sweden in 2007?
Provide a short and direct response. -5.26. What is the difference between the Unemployed and educated female labor force (% of population) of High income: OECD in 2004 and the Unemployed and educated female labor force (% of population) of Mexico in 2007?
Make the answer very short. -12.11. What is the difference between the Unemployed and educated female labor force (% of population) in High income: OECD in 2004 and the Unemployed and educated female labor force (% of population) in Sweden in 2007?
Provide a succinct answer. -1.01. What is the difference between the Unemployed and educated female labor force (% of population) in Europe(all income levels) in 2005 and the Unemployed and educated female labor force (% of population) in High income: OECD in 2006?
Ensure brevity in your answer.  -3.89. What is the difference between the Unemployed and educated female labor force (% of population) in Europe(all income levels) in 2005 and the Unemployed and educated female labor force (% of population) in Mexico in 2006?
Offer a terse response. -19.17. What is the difference between the Unemployed and educated female labor force (% of population) of Europe(all income levels) in 2005 and the Unemployed and educated female labor force (% of population) of Sweden in 2006?
Give a very brief answer. -2.77. What is the difference between the Unemployed and educated female labor force (% of population) in High income: OECD in 2005 and the Unemployed and educated female labor force (% of population) in Mexico in 2006?
Provide a succinct answer. -15.31. What is the difference between the Unemployed and educated female labor force (% of population) in High income: OECD in 2005 and the Unemployed and educated female labor force (% of population) in Sweden in 2006?
Ensure brevity in your answer.  1.09. What is the difference between the Unemployed and educated female labor force (% of population) in Mexico in 2005 and the Unemployed and educated female labor force (% of population) in Sweden in 2006?
Offer a very short reply. 16.9. What is the difference between the Unemployed and educated female labor force (% of population) of Europe(all income levels) in 2005 and the Unemployed and educated female labor force (% of population) of High income: OECD in 2007?
Your answer should be compact. -4.06. What is the difference between the Unemployed and educated female labor force (% of population) in Europe(all income levels) in 2005 and the Unemployed and educated female labor force (% of population) in Mexico in 2007?
Offer a terse response. -16.27. What is the difference between the Unemployed and educated female labor force (% of population) in Europe(all income levels) in 2005 and the Unemployed and educated female labor force (% of population) in Sweden in 2007?
Your answer should be very brief. -5.17. What is the difference between the Unemployed and educated female labor force (% of population) in High income: OECD in 2005 and the Unemployed and educated female labor force (% of population) in Mexico in 2007?
Provide a short and direct response. -12.41. What is the difference between the Unemployed and educated female labor force (% of population) in High income: OECD in 2005 and the Unemployed and educated female labor force (% of population) in Sweden in 2007?
Make the answer very short. -1.31. What is the difference between the Unemployed and educated female labor force (% of population) of Europe(all income levels) in 2006 and the Unemployed and educated female labor force (% of population) of High income: OECD in 2007?
Make the answer very short. -3.4. What is the difference between the Unemployed and educated female labor force (% of population) in Europe(all income levels) in 2006 and the Unemployed and educated female labor force (% of population) in Mexico in 2007?
Your answer should be very brief. -15.61. What is the difference between the Unemployed and educated female labor force (% of population) in Europe(all income levels) in 2006 and the Unemployed and educated female labor force (% of population) in Sweden in 2007?
Make the answer very short. -4.51. What is the difference between the Unemployed and educated female labor force (% of population) of High income: OECD in 2006 and the Unemployed and educated female labor force (% of population) of Mexico in 2007?
Provide a succinct answer. -12.38. What is the difference between the Unemployed and educated female labor force (% of population) in High income: OECD in 2006 and the Unemployed and educated female labor force (% of population) in Sweden in 2007?
Ensure brevity in your answer.  -1.28. What is the difference between the Unemployed and educated female labor force (% of population) of Mexico in 2006 and the Unemployed and educated female labor force (% of population) of Sweden in 2007?
Your response must be concise. 14. What is the average Unemployed and educated female labor force (% of population) in Europe(all income levels) per year?
Offer a very short reply. 27.34. What is the average Unemployed and educated female labor force (% of population) of High income: OECD per year?
Give a very brief answer. 31.08. What is the average Unemployed and educated female labor force (% of population) in Mexico per year?
Give a very brief answer. 46.95. What is the average Unemployed and educated female labor force (% of population) of Sweden per year?
Offer a very short reply. 29.07. In the year 2000, what is the difference between the Unemployed and educated female labor force (% of population) in Europe(all income levels) and Unemployed and educated female labor force (% of population) in High income: OECD?
Provide a succinct answer. -3.92. In the year 2000, what is the difference between the Unemployed and educated female labor force (% of population) in Europe(all income levels) and Unemployed and educated female labor force (% of population) in Mexico?
Provide a succinct answer. -19.42. In the year 2000, what is the difference between the Unemployed and educated female labor force (% of population) in Europe(all income levels) and Unemployed and educated female labor force (% of population) in Sweden?
Offer a very short reply. -2.92. In the year 2000, what is the difference between the Unemployed and educated female labor force (% of population) of High income: OECD and Unemployed and educated female labor force (% of population) of Mexico?
Offer a terse response. -15.5. In the year 2001, what is the difference between the Unemployed and educated female labor force (% of population) of Europe(all income levels) and Unemployed and educated female labor force (% of population) of High income: OECD?
Offer a very short reply. -1.45. In the year 2001, what is the difference between the Unemployed and educated female labor force (% of population) of Europe(all income levels) and Unemployed and educated female labor force (% of population) of Mexico?
Give a very brief answer. -21.86. In the year 2001, what is the difference between the Unemployed and educated female labor force (% of population) in Europe(all income levels) and Unemployed and educated female labor force (% of population) in Sweden?
Offer a terse response. -1.46. In the year 2001, what is the difference between the Unemployed and educated female labor force (% of population) in High income: OECD and Unemployed and educated female labor force (% of population) in Mexico?
Offer a terse response. -20.41. In the year 2001, what is the difference between the Unemployed and educated female labor force (% of population) in High income: OECD and Unemployed and educated female labor force (% of population) in Sweden?
Make the answer very short. -0.01. In the year 2001, what is the difference between the Unemployed and educated female labor force (% of population) of Mexico and Unemployed and educated female labor force (% of population) of Sweden?
Make the answer very short. 20.4. In the year 2002, what is the difference between the Unemployed and educated female labor force (% of population) in Europe(all income levels) and Unemployed and educated female labor force (% of population) in High income: OECD?
Offer a terse response. -4.85. In the year 2002, what is the difference between the Unemployed and educated female labor force (% of population) in Europe(all income levels) and Unemployed and educated female labor force (% of population) in Mexico?
Your response must be concise. -22.2. In the year 2002, what is the difference between the Unemployed and educated female labor force (% of population) of Europe(all income levels) and Unemployed and educated female labor force (% of population) of Sweden?
Give a very brief answer. -2.4. In the year 2002, what is the difference between the Unemployed and educated female labor force (% of population) in High income: OECD and Unemployed and educated female labor force (% of population) in Mexico?
Give a very brief answer. -17.34. In the year 2002, what is the difference between the Unemployed and educated female labor force (% of population) of High income: OECD and Unemployed and educated female labor force (% of population) of Sweden?
Your response must be concise. 2.46. In the year 2002, what is the difference between the Unemployed and educated female labor force (% of population) of Mexico and Unemployed and educated female labor force (% of population) of Sweden?
Your response must be concise. 19.8. In the year 2003, what is the difference between the Unemployed and educated female labor force (% of population) in Europe(all income levels) and Unemployed and educated female labor force (% of population) in High income: OECD?
Your response must be concise. -4.97. In the year 2003, what is the difference between the Unemployed and educated female labor force (% of population) of Europe(all income levels) and Unemployed and educated female labor force (% of population) of Mexico?
Give a very brief answer. -21.15. In the year 2003, what is the difference between the Unemployed and educated female labor force (% of population) of Europe(all income levels) and Unemployed and educated female labor force (% of population) of Sweden?
Give a very brief answer. -1.45. In the year 2003, what is the difference between the Unemployed and educated female labor force (% of population) in High income: OECD and Unemployed and educated female labor force (% of population) in Mexico?
Provide a succinct answer. -16.18. In the year 2003, what is the difference between the Unemployed and educated female labor force (% of population) in High income: OECD and Unemployed and educated female labor force (% of population) in Sweden?
Give a very brief answer. 3.52. In the year 2004, what is the difference between the Unemployed and educated female labor force (% of population) in Europe(all income levels) and Unemployed and educated female labor force (% of population) in High income: OECD?
Your answer should be very brief. -4.25. In the year 2004, what is the difference between the Unemployed and educated female labor force (% of population) of Europe(all income levels) and Unemployed and educated female labor force (% of population) of Mexico?
Your answer should be compact. -18.46. In the year 2004, what is the difference between the Unemployed and educated female labor force (% of population) of Europe(all income levels) and Unemployed and educated female labor force (% of population) of Sweden?
Make the answer very short. 2.74. In the year 2004, what is the difference between the Unemployed and educated female labor force (% of population) in High income: OECD and Unemployed and educated female labor force (% of population) in Mexico?
Your answer should be compact. -14.21. In the year 2004, what is the difference between the Unemployed and educated female labor force (% of population) in High income: OECD and Unemployed and educated female labor force (% of population) in Sweden?
Your response must be concise. 6.99. In the year 2004, what is the difference between the Unemployed and educated female labor force (% of population) in Mexico and Unemployed and educated female labor force (% of population) in Sweden?
Ensure brevity in your answer.  21.2. In the year 2005, what is the difference between the Unemployed and educated female labor force (% of population) of Europe(all income levels) and Unemployed and educated female labor force (% of population) of High income: OECD?
Give a very brief answer. -3.86. In the year 2005, what is the difference between the Unemployed and educated female labor force (% of population) of Europe(all income levels) and Unemployed and educated female labor force (% of population) of Mexico?
Offer a terse response. -19.67. In the year 2005, what is the difference between the Unemployed and educated female labor force (% of population) of Europe(all income levels) and Unemployed and educated female labor force (% of population) of Sweden?
Provide a succinct answer. -1.77. In the year 2005, what is the difference between the Unemployed and educated female labor force (% of population) in High income: OECD and Unemployed and educated female labor force (% of population) in Mexico?
Offer a terse response. -15.81. In the year 2005, what is the difference between the Unemployed and educated female labor force (% of population) of High income: OECD and Unemployed and educated female labor force (% of population) of Sweden?
Your response must be concise. 2.09. In the year 2005, what is the difference between the Unemployed and educated female labor force (% of population) of Mexico and Unemployed and educated female labor force (% of population) of Sweden?
Your answer should be very brief. 17.9. In the year 2006, what is the difference between the Unemployed and educated female labor force (% of population) in Europe(all income levels) and Unemployed and educated female labor force (% of population) in High income: OECD?
Give a very brief answer. -3.23. In the year 2006, what is the difference between the Unemployed and educated female labor force (% of population) of Europe(all income levels) and Unemployed and educated female labor force (% of population) of Mexico?
Your answer should be very brief. -18.51. In the year 2006, what is the difference between the Unemployed and educated female labor force (% of population) in Europe(all income levels) and Unemployed and educated female labor force (% of population) in Sweden?
Give a very brief answer. -2.11. In the year 2006, what is the difference between the Unemployed and educated female labor force (% of population) of High income: OECD and Unemployed and educated female labor force (% of population) of Mexico?
Your answer should be very brief. -15.28. In the year 2006, what is the difference between the Unemployed and educated female labor force (% of population) of High income: OECD and Unemployed and educated female labor force (% of population) of Sweden?
Provide a succinct answer. 1.12. In the year 2007, what is the difference between the Unemployed and educated female labor force (% of population) of Europe(all income levels) and Unemployed and educated female labor force (% of population) of High income: OECD?
Offer a terse response. -3.38. In the year 2007, what is the difference between the Unemployed and educated female labor force (% of population) of Europe(all income levels) and Unemployed and educated female labor force (% of population) of Mexico?
Ensure brevity in your answer.  -15.59. In the year 2007, what is the difference between the Unemployed and educated female labor force (% of population) of Europe(all income levels) and Unemployed and educated female labor force (% of population) of Sweden?
Provide a succinct answer. -4.49. In the year 2007, what is the difference between the Unemployed and educated female labor force (% of population) in High income: OECD and Unemployed and educated female labor force (% of population) in Mexico?
Make the answer very short. -12.21. In the year 2007, what is the difference between the Unemployed and educated female labor force (% of population) of High income: OECD and Unemployed and educated female labor force (% of population) of Sweden?
Provide a succinct answer. -1.11. In the year 2007, what is the difference between the Unemployed and educated female labor force (% of population) in Mexico and Unemployed and educated female labor force (% of population) in Sweden?
Provide a short and direct response. 11.1. What is the ratio of the Unemployed and educated female labor force (% of population) in Europe(all income levels) in 2000 to that in 2001?
Your answer should be compact. 0.99. What is the ratio of the Unemployed and educated female labor force (% of population) of High income: OECD in 2000 to that in 2001?
Keep it short and to the point. 1.08. What is the ratio of the Unemployed and educated female labor force (% of population) of Mexico in 2000 to that in 2001?
Make the answer very short. 0.95. What is the ratio of the Unemployed and educated female labor force (% of population) of Sweden in 2000 to that in 2001?
Offer a very short reply. 1.04. What is the ratio of the Unemployed and educated female labor force (% of population) of Europe(all income levels) in 2000 to that in 2002?
Give a very brief answer. 1.01. What is the ratio of the Unemployed and educated female labor force (% of population) of High income: OECD in 2000 to that in 2002?
Provide a succinct answer. 0.98. What is the ratio of the Unemployed and educated female labor force (% of population) of Mexico in 2000 to that in 2002?
Your answer should be very brief. 0.95. What is the ratio of the Unemployed and educated female labor force (% of population) in Sweden in 2000 to that in 2002?
Keep it short and to the point. 1.03. What is the ratio of the Unemployed and educated female labor force (% of population) in Europe(all income levels) in 2000 to that in 2003?
Your answer should be very brief. 1.03. What is the ratio of the Unemployed and educated female labor force (% of population) of High income: OECD in 2000 to that in 2003?
Give a very brief answer. 1. What is the ratio of the Unemployed and educated female labor force (% of population) in Mexico in 2000 to that in 2003?
Your answer should be compact. 0.98. What is the ratio of the Unemployed and educated female labor force (% of population) of Sweden in 2000 to that in 2003?
Offer a terse response. 1.09. What is the ratio of the Unemployed and educated female labor force (% of population) in Europe(all income levels) in 2000 to that in 2004?
Your answer should be compact. 1.03. What is the ratio of the Unemployed and educated female labor force (% of population) in High income: OECD in 2000 to that in 2004?
Offer a terse response. 1.02. What is the ratio of the Unemployed and educated female labor force (% of population) of Mexico in 2000 to that in 2004?
Provide a succinct answer. 1.04. What is the ratio of the Unemployed and educated female labor force (% of population) in Sweden in 2000 to that in 2004?
Make the answer very short. 1.27. What is the ratio of the Unemployed and educated female labor force (% of population) of Europe(all income levels) in 2000 to that in 2005?
Keep it short and to the point. 1.03. What is the ratio of the Unemployed and educated female labor force (% of population) of High income: OECD in 2000 to that in 2005?
Your answer should be very brief. 1.03. What is the ratio of the Unemployed and educated female labor force (% of population) of Mexico in 2000 to that in 2005?
Make the answer very short. 1.01. What is the ratio of the Unemployed and educated female labor force (% of population) in Sweden in 2000 to that in 2005?
Offer a terse response. 1.07. What is the ratio of the Unemployed and educated female labor force (% of population) of Europe(all income levels) in 2000 to that in 2006?
Provide a succinct answer. 1. What is the ratio of the Unemployed and educated female labor force (% of population) in High income: OECD in 2000 to that in 2006?
Your answer should be very brief. 1.03. What is the ratio of the Unemployed and educated female labor force (% of population) of Mexico in 2000 to that in 2006?
Provide a short and direct response. 1.02. What is the ratio of the Unemployed and educated female labor force (% of population) in Sweden in 2000 to that in 2006?
Offer a terse response. 1.03. What is the ratio of the Unemployed and educated female labor force (% of population) in Europe(all income levels) in 2000 to that in 2007?
Your answer should be very brief. 1. What is the ratio of the Unemployed and educated female labor force (% of population) of High income: OECD in 2000 to that in 2007?
Your answer should be compact. 1.02. What is the ratio of the Unemployed and educated female labor force (% of population) of Mexico in 2000 to that in 2007?
Offer a very short reply. 1.09. What is the ratio of the Unemployed and educated female labor force (% of population) in Sweden in 2000 to that in 2007?
Provide a succinct answer. 0.95. What is the ratio of the Unemployed and educated female labor force (% of population) of Europe(all income levels) in 2001 to that in 2002?
Your answer should be very brief. 1.02. What is the ratio of the Unemployed and educated female labor force (% of population) in High income: OECD in 2001 to that in 2002?
Offer a very short reply. 0.91. What is the ratio of the Unemployed and educated female labor force (% of population) in Sweden in 2001 to that in 2002?
Your response must be concise. 0.99. What is the ratio of the Unemployed and educated female labor force (% of population) of Europe(all income levels) in 2001 to that in 2003?
Your answer should be compact. 1.04. What is the ratio of the Unemployed and educated female labor force (% of population) of High income: OECD in 2001 to that in 2003?
Make the answer very short. 0.93. What is the ratio of the Unemployed and educated female labor force (% of population) in Mexico in 2001 to that in 2003?
Your answer should be very brief. 1.04. What is the ratio of the Unemployed and educated female labor force (% of population) of Sweden in 2001 to that in 2003?
Give a very brief answer. 1.04. What is the ratio of the Unemployed and educated female labor force (% of population) of Europe(all income levels) in 2001 to that in 2004?
Give a very brief answer. 1.04. What is the ratio of the Unemployed and educated female labor force (% of population) in High income: OECD in 2001 to that in 2004?
Ensure brevity in your answer.  0.95. What is the ratio of the Unemployed and educated female labor force (% of population) in Mexico in 2001 to that in 2004?
Offer a very short reply. 1.1. What is the ratio of the Unemployed and educated female labor force (% of population) in Sweden in 2001 to that in 2004?
Offer a terse response. 1.22. What is the ratio of the Unemployed and educated female labor force (% of population) of Europe(all income levels) in 2001 to that in 2005?
Provide a short and direct response. 1.04. What is the ratio of the Unemployed and educated female labor force (% of population) of High income: OECD in 2001 to that in 2005?
Your response must be concise. 0.95. What is the ratio of the Unemployed and educated female labor force (% of population) of Mexico in 2001 to that in 2005?
Keep it short and to the point. 1.07. What is the ratio of the Unemployed and educated female labor force (% of population) in Sweden in 2001 to that in 2005?
Keep it short and to the point. 1.02. What is the ratio of the Unemployed and educated female labor force (% of population) of Europe(all income levels) in 2001 to that in 2006?
Your answer should be very brief. 1.01. What is the ratio of the Unemployed and educated female labor force (% of population) in High income: OECD in 2001 to that in 2006?
Make the answer very short. 0.95. What is the ratio of the Unemployed and educated female labor force (% of population) of Mexico in 2001 to that in 2006?
Make the answer very short. 1.08. What is the ratio of the Unemployed and educated female labor force (% of population) in Sweden in 2001 to that in 2006?
Make the answer very short. 0.99. What is the ratio of the Unemployed and educated female labor force (% of population) in High income: OECD in 2001 to that in 2007?
Keep it short and to the point. 0.95. What is the ratio of the Unemployed and educated female labor force (% of population) of Mexico in 2001 to that in 2007?
Provide a succinct answer. 1.15. What is the ratio of the Unemployed and educated female labor force (% of population) of Sweden in 2001 to that in 2007?
Make the answer very short. 0.92. What is the ratio of the Unemployed and educated female labor force (% of population) of Europe(all income levels) in 2002 to that in 2003?
Provide a short and direct response. 1.02. What is the ratio of the Unemployed and educated female labor force (% of population) in High income: OECD in 2002 to that in 2003?
Your response must be concise. 1.02. What is the ratio of the Unemployed and educated female labor force (% of population) of Mexico in 2002 to that in 2003?
Ensure brevity in your answer.  1.04. What is the ratio of the Unemployed and educated female labor force (% of population) in Sweden in 2002 to that in 2003?
Make the answer very short. 1.06. What is the ratio of the Unemployed and educated female labor force (% of population) of Europe(all income levels) in 2002 to that in 2004?
Give a very brief answer. 1.02. What is the ratio of the Unemployed and educated female labor force (% of population) in High income: OECD in 2002 to that in 2004?
Keep it short and to the point. 1.04. What is the ratio of the Unemployed and educated female labor force (% of population) in Mexico in 2002 to that in 2004?
Your answer should be very brief. 1.09. What is the ratio of the Unemployed and educated female labor force (% of population) in Sweden in 2002 to that in 2004?
Give a very brief answer. 1.24. What is the ratio of the Unemployed and educated female labor force (% of population) of Europe(all income levels) in 2002 to that in 2005?
Your answer should be compact. 1.02. What is the ratio of the Unemployed and educated female labor force (% of population) of High income: OECD in 2002 to that in 2005?
Your answer should be compact. 1.05. What is the ratio of the Unemployed and educated female labor force (% of population) in Mexico in 2002 to that in 2005?
Give a very brief answer. 1.06. What is the ratio of the Unemployed and educated female labor force (% of population) of Sweden in 2002 to that in 2005?
Your answer should be very brief. 1.04. What is the ratio of the Unemployed and educated female labor force (% of population) of High income: OECD in 2002 to that in 2006?
Provide a short and direct response. 1.05. What is the ratio of the Unemployed and educated female labor force (% of population) in Mexico in 2002 to that in 2006?
Give a very brief answer. 1.08. What is the ratio of the Unemployed and educated female labor force (% of population) of Sweden in 2002 to that in 2006?
Offer a very short reply. 1. What is the ratio of the Unemployed and educated female labor force (% of population) in Europe(all income levels) in 2002 to that in 2007?
Your answer should be compact. 0.99. What is the ratio of the Unemployed and educated female labor force (% of population) of High income: OECD in 2002 to that in 2007?
Your answer should be compact. 1.04. What is the ratio of the Unemployed and educated female labor force (% of population) in Mexico in 2002 to that in 2007?
Make the answer very short. 1.15. What is the ratio of the Unemployed and educated female labor force (% of population) of Sweden in 2002 to that in 2007?
Offer a terse response. 0.93. What is the ratio of the Unemployed and educated female labor force (% of population) in High income: OECD in 2003 to that in 2004?
Give a very brief answer. 1.02. What is the ratio of the Unemployed and educated female labor force (% of population) of Mexico in 2003 to that in 2004?
Offer a terse response. 1.06. What is the ratio of the Unemployed and educated female labor force (% of population) in Sweden in 2003 to that in 2004?
Offer a very short reply. 1.17. What is the ratio of the Unemployed and educated female labor force (% of population) in Europe(all income levels) in 2003 to that in 2005?
Provide a succinct answer. 0.99. What is the ratio of the Unemployed and educated female labor force (% of population) of High income: OECD in 2003 to that in 2005?
Provide a short and direct response. 1.03. What is the ratio of the Unemployed and educated female labor force (% of population) in Mexico in 2003 to that in 2005?
Ensure brevity in your answer.  1.03. What is the ratio of the Unemployed and educated female labor force (% of population) in Sweden in 2003 to that in 2005?
Make the answer very short. 0.98. What is the ratio of the Unemployed and educated female labor force (% of population) in Europe(all income levels) in 2003 to that in 2006?
Your answer should be compact. 0.97. What is the ratio of the Unemployed and educated female labor force (% of population) in High income: OECD in 2003 to that in 2006?
Your response must be concise. 1.03. What is the ratio of the Unemployed and educated female labor force (% of population) in Mexico in 2003 to that in 2006?
Your response must be concise. 1.04. What is the ratio of the Unemployed and educated female labor force (% of population) in Sweden in 2003 to that in 2006?
Offer a very short reply. 0.95. What is the ratio of the Unemployed and educated female labor force (% of population) of Europe(all income levels) in 2003 to that in 2007?
Provide a succinct answer. 0.97. What is the ratio of the Unemployed and educated female labor force (% of population) of High income: OECD in 2003 to that in 2007?
Provide a short and direct response. 1.02. What is the ratio of the Unemployed and educated female labor force (% of population) of Mexico in 2003 to that in 2007?
Your answer should be very brief. 1.11. What is the ratio of the Unemployed and educated female labor force (% of population) in Sweden in 2003 to that in 2007?
Ensure brevity in your answer.  0.88. What is the ratio of the Unemployed and educated female labor force (% of population) in High income: OECD in 2004 to that in 2005?
Keep it short and to the point. 1.01. What is the ratio of the Unemployed and educated female labor force (% of population) of Mexico in 2004 to that in 2005?
Your answer should be very brief. 0.97. What is the ratio of the Unemployed and educated female labor force (% of population) in Sweden in 2004 to that in 2005?
Offer a terse response. 0.84. What is the ratio of the Unemployed and educated female labor force (% of population) of Europe(all income levels) in 2004 to that in 2006?
Ensure brevity in your answer.  0.97. What is the ratio of the Unemployed and educated female labor force (% of population) in High income: OECD in 2004 to that in 2006?
Provide a short and direct response. 1.01. What is the ratio of the Unemployed and educated female labor force (% of population) of Mexico in 2004 to that in 2006?
Your answer should be very brief. 0.98. What is the ratio of the Unemployed and educated female labor force (% of population) of Sweden in 2004 to that in 2006?
Keep it short and to the point. 0.81. What is the ratio of the Unemployed and educated female labor force (% of population) of Europe(all income levels) in 2004 to that in 2007?
Provide a short and direct response. 0.97. What is the ratio of the Unemployed and educated female labor force (% of population) in High income: OECD in 2004 to that in 2007?
Make the answer very short. 1. What is the ratio of the Unemployed and educated female labor force (% of population) in Mexico in 2004 to that in 2007?
Make the answer very short. 1.05. What is the ratio of the Unemployed and educated female labor force (% of population) in Sweden in 2004 to that in 2007?
Provide a short and direct response. 0.75. What is the ratio of the Unemployed and educated female labor force (% of population) in Europe(all income levels) in 2005 to that in 2006?
Your answer should be very brief. 0.98. What is the ratio of the Unemployed and educated female labor force (% of population) in High income: OECD in 2005 to that in 2006?
Your response must be concise. 1. What is the ratio of the Unemployed and educated female labor force (% of population) of Mexico in 2005 to that in 2006?
Give a very brief answer. 1.01. What is the ratio of the Unemployed and educated female labor force (% of population) in Sweden in 2005 to that in 2006?
Provide a succinct answer. 0.97. What is the ratio of the Unemployed and educated female labor force (% of population) of Europe(all income levels) in 2005 to that in 2007?
Your answer should be compact. 0.98. What is the ratio of the Unemployed and educated female labor force (% of population) in Mexico in 2005 to that in 2007?
Give a very brief answer. 1.08. What is the ratio of the Unemployed and educated female labor force (% of population) of Sweden in 2005 to that in 2007?
Your response must be concise. 0.89. What is the ratio of the Unemployed and educated female labor force (% of population) of Mexico in 2006 to that in 2007?
Give a very brief answer. 1.07. What is the ratio of the Unemployed and educated female labor force (% of population) of Sweden in 2006 to that in 2007?
Your answer should be compact. 0.93. What is the difference between the highest and the second highest Unemployed and educated female labor force (% of population) in Europe(all income levels)?
Offer a terse response. 0.26. What is the difference between the highest and the second highest Unemployed and educated female labor force (% of population) in High income: OECD?
Give a very brief answer. 0.53. What is the difference between the highest and the second highest Unemployed and educated female labor force (% of population) in Mexico?
Ensure brevity in your answer.  0.2. What is the difference between the highest and the lowest Unemployed and educated female labor force (% of population) of Europe(all income levels)?
Provide a succinct answer. 1.19. What is the difference between the highest and the lowest Unemployed and educated female labor force (% of population) of High income: OECD?
Your response must be concise. 2.86. What is the difference between the highest and the lowest Unemployed and educated female labor force (% of population) of Mexico?
Offer a terse response. 6.6. 